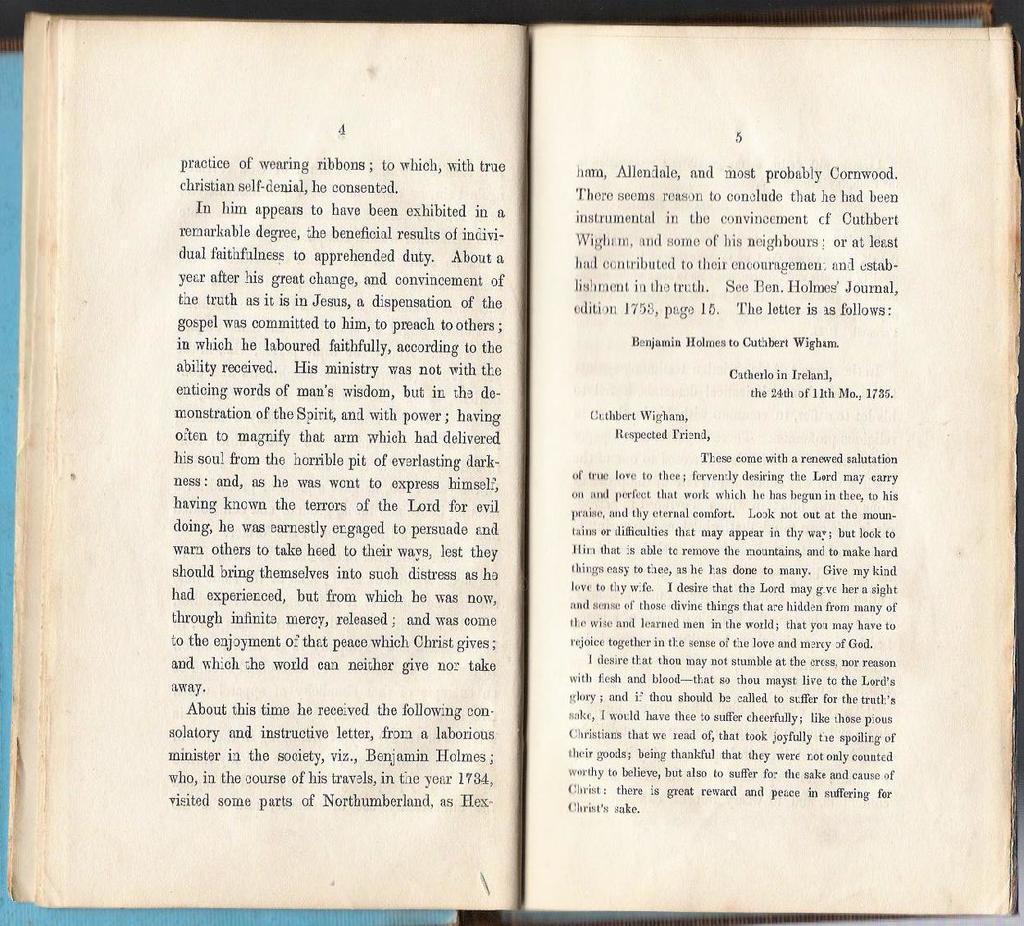Describe this image in one or two sentences. In this picture we can see a book. On the papers, it is written something. Behind the book, there is an object. 